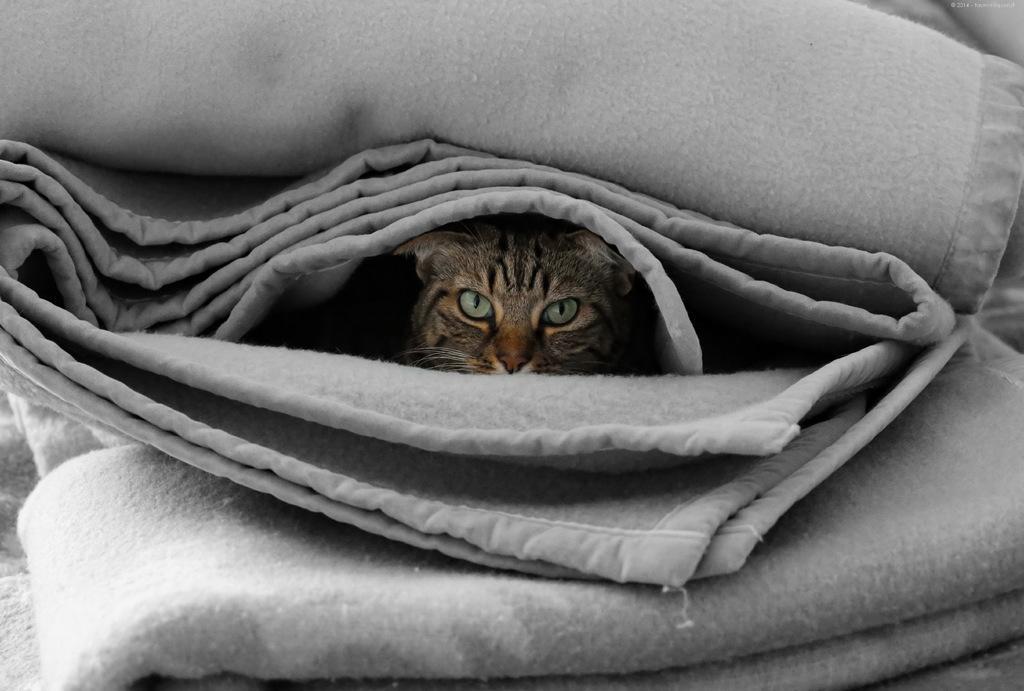Describe this image in one or two sentences. In the image in the center we can see blankets,which is in ash color. In the blanket,we can see one cat. 